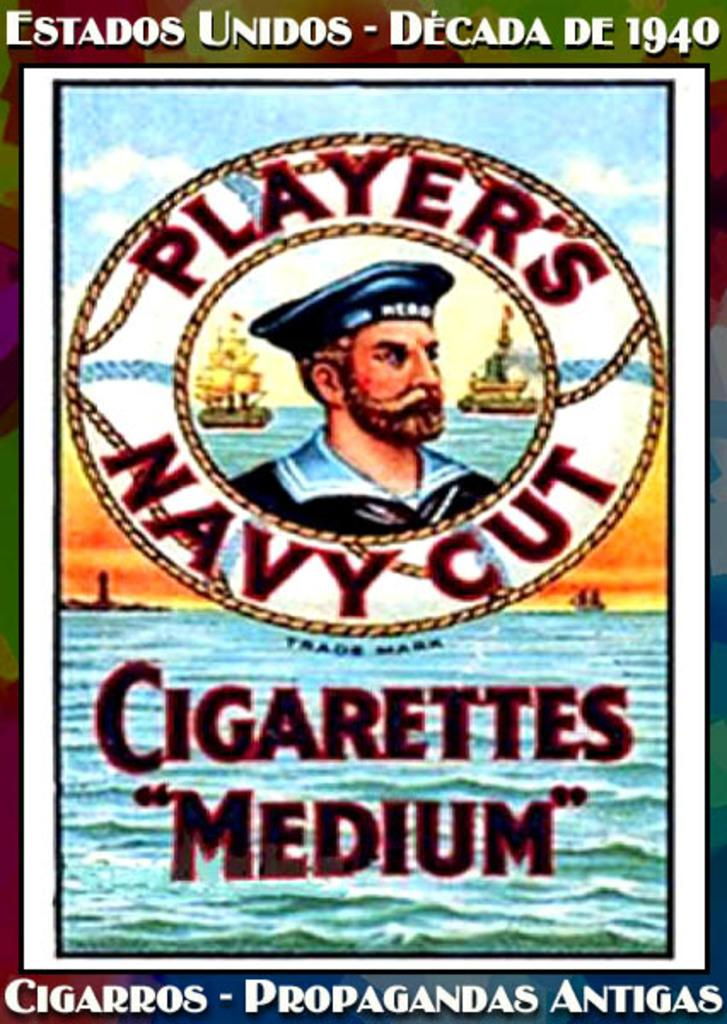<image>
Relay a brief, clear account of the picture shown. A poster displaying a cigarette ad from the 1940s in the United States 